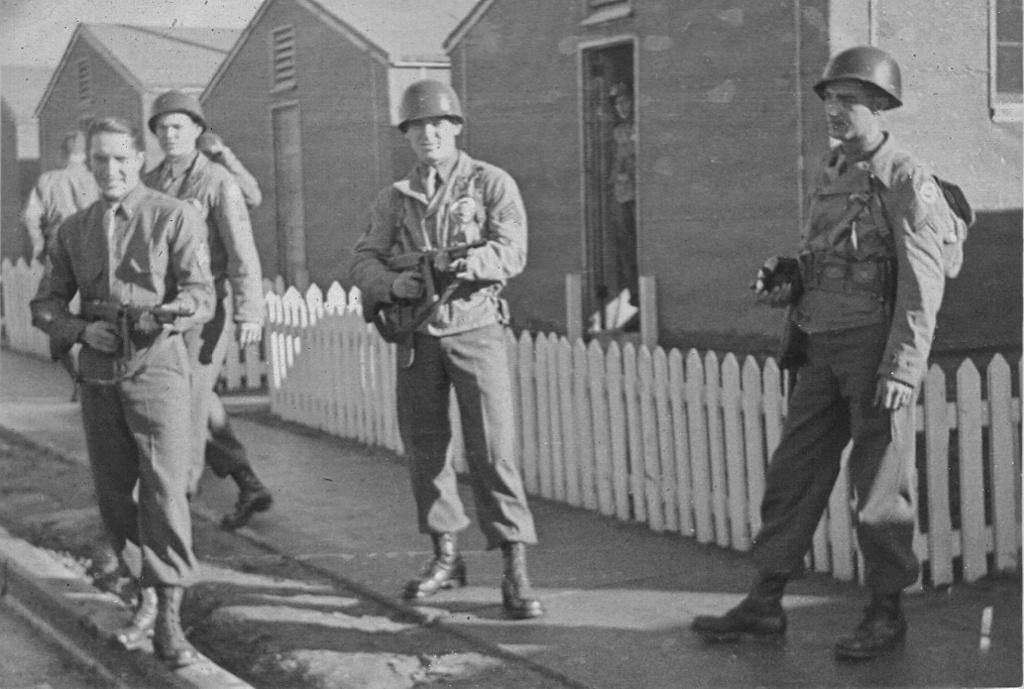What is the color scheme of the image? The image is black and white. What can be seen in the image? There are people standing in the image. What are the people holding in their hands? The people are holding guns in their hands. What is visible in the background of the image? There are houses and the sky visible in the background of the image. What type of quartz can be seen in the hands of the people in the image? There is no quartz present in the image; the people are holding guns. What kind of toy is being played with by the people in the image? There are no toys visible in the image; the people are holding guns. 